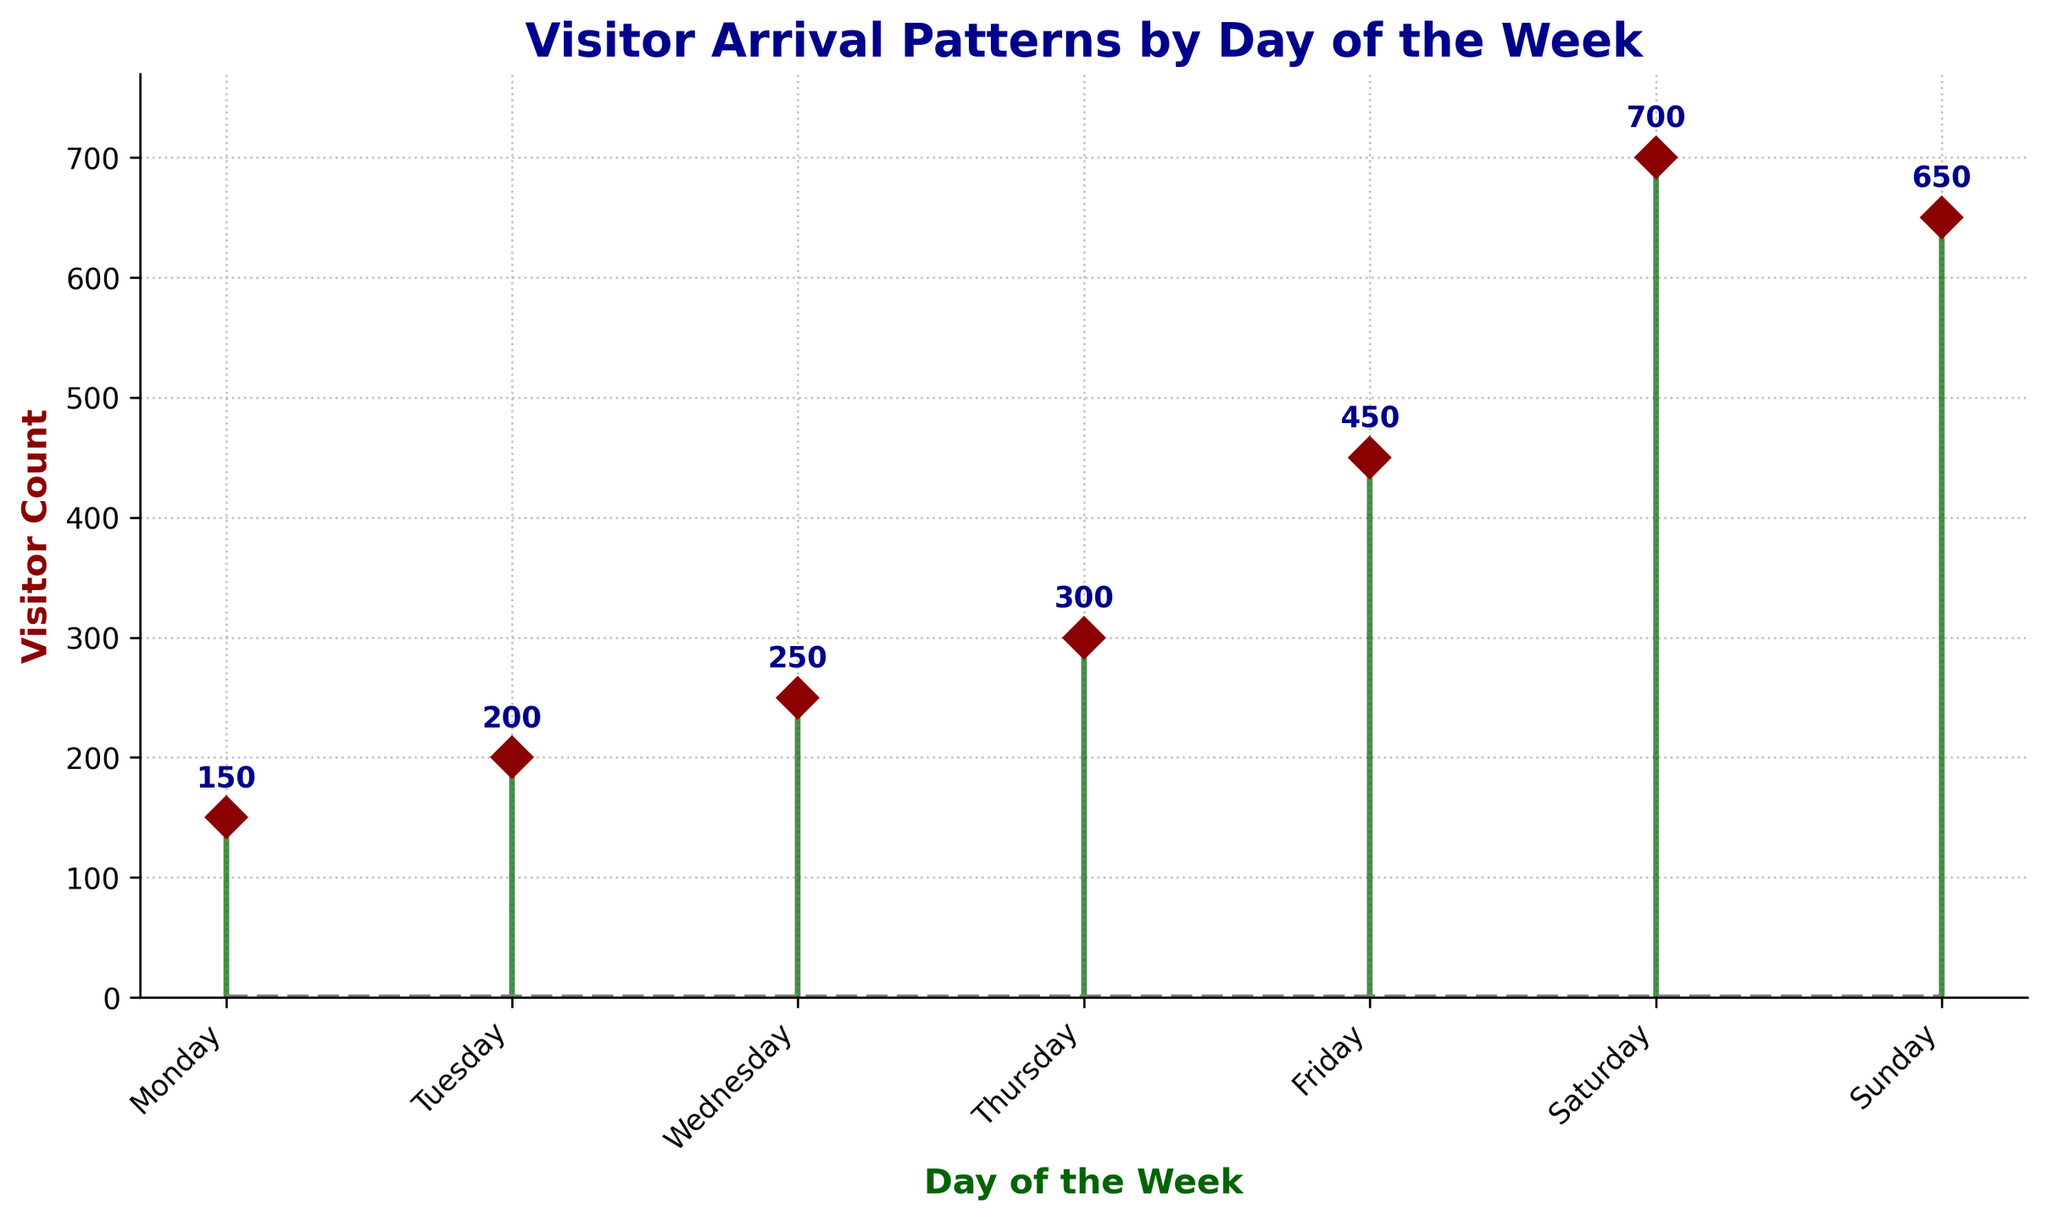What's the title of the figure? The title is displayed at the top of the figure in bold letters.
Answer: Visitor Arrival Patterns by Day of the Week What's the highest visitor count, and on which day does it occur? The highest point on the stem plot represents the day with the highest visitor count, and the count value is written above the stem.
Answer: 700 on Saturday What's the difference in visitor count between Friday and Sunday? The visitor count on Friday is 450, and on Sunday, it is 650. Subtract Friday's count from Sunday's. 650 - 450 = 200
Answer: 200 What's the total visitor count for the weekend (Saturday and Sunday)? Add the visitor counts for Saturday and Sunday. 700 (Saturday) + 650 (Sunday) = 1350
Answer: 1350 Which day has the lowest visitor count, and what is that count? The lowest point on the stem plot shows the day with the least visitors.
Answer: 150 on Monday What's the average visitor count across all days of the week? Add all visitor counts and divide by the number of days. (150 + 200 + 250 + 300 + 450 + 700 + 650) / 7 = 2700 / 7 ≈ 385.71
Answer: ≈ 385.71 How much does the visitor count increase from Thursday to Saturday? Subtract the visitor count on Thursday from the count on Saturday. 700 (Saturday) - 300 (Thursday) = 400
Answer: 400 Which day has the closest visitor count to the average visitor count? After calculating the average (≈385.71), identify the day whose visitor count is closest to this average. 450 (Friday) - 385.71 ≈ 64.29; 300 (Thursday) - 385.71 ≈ -85.71. 450 is closer.
Answer: Friday What trend can you observe in visitor counts from Monday to Sunday? By examining the stem positions and sizes from left (Monday) to right (Sunday), we see if counts generally rise or fall. Visitor counts steadily increase mid-week and peak during the weekend.
Answer: Increasing trend On which days does the visitor count surpass 500? Identify the days where the stem exceeds 500.
Answer: Saturday and Sunday 